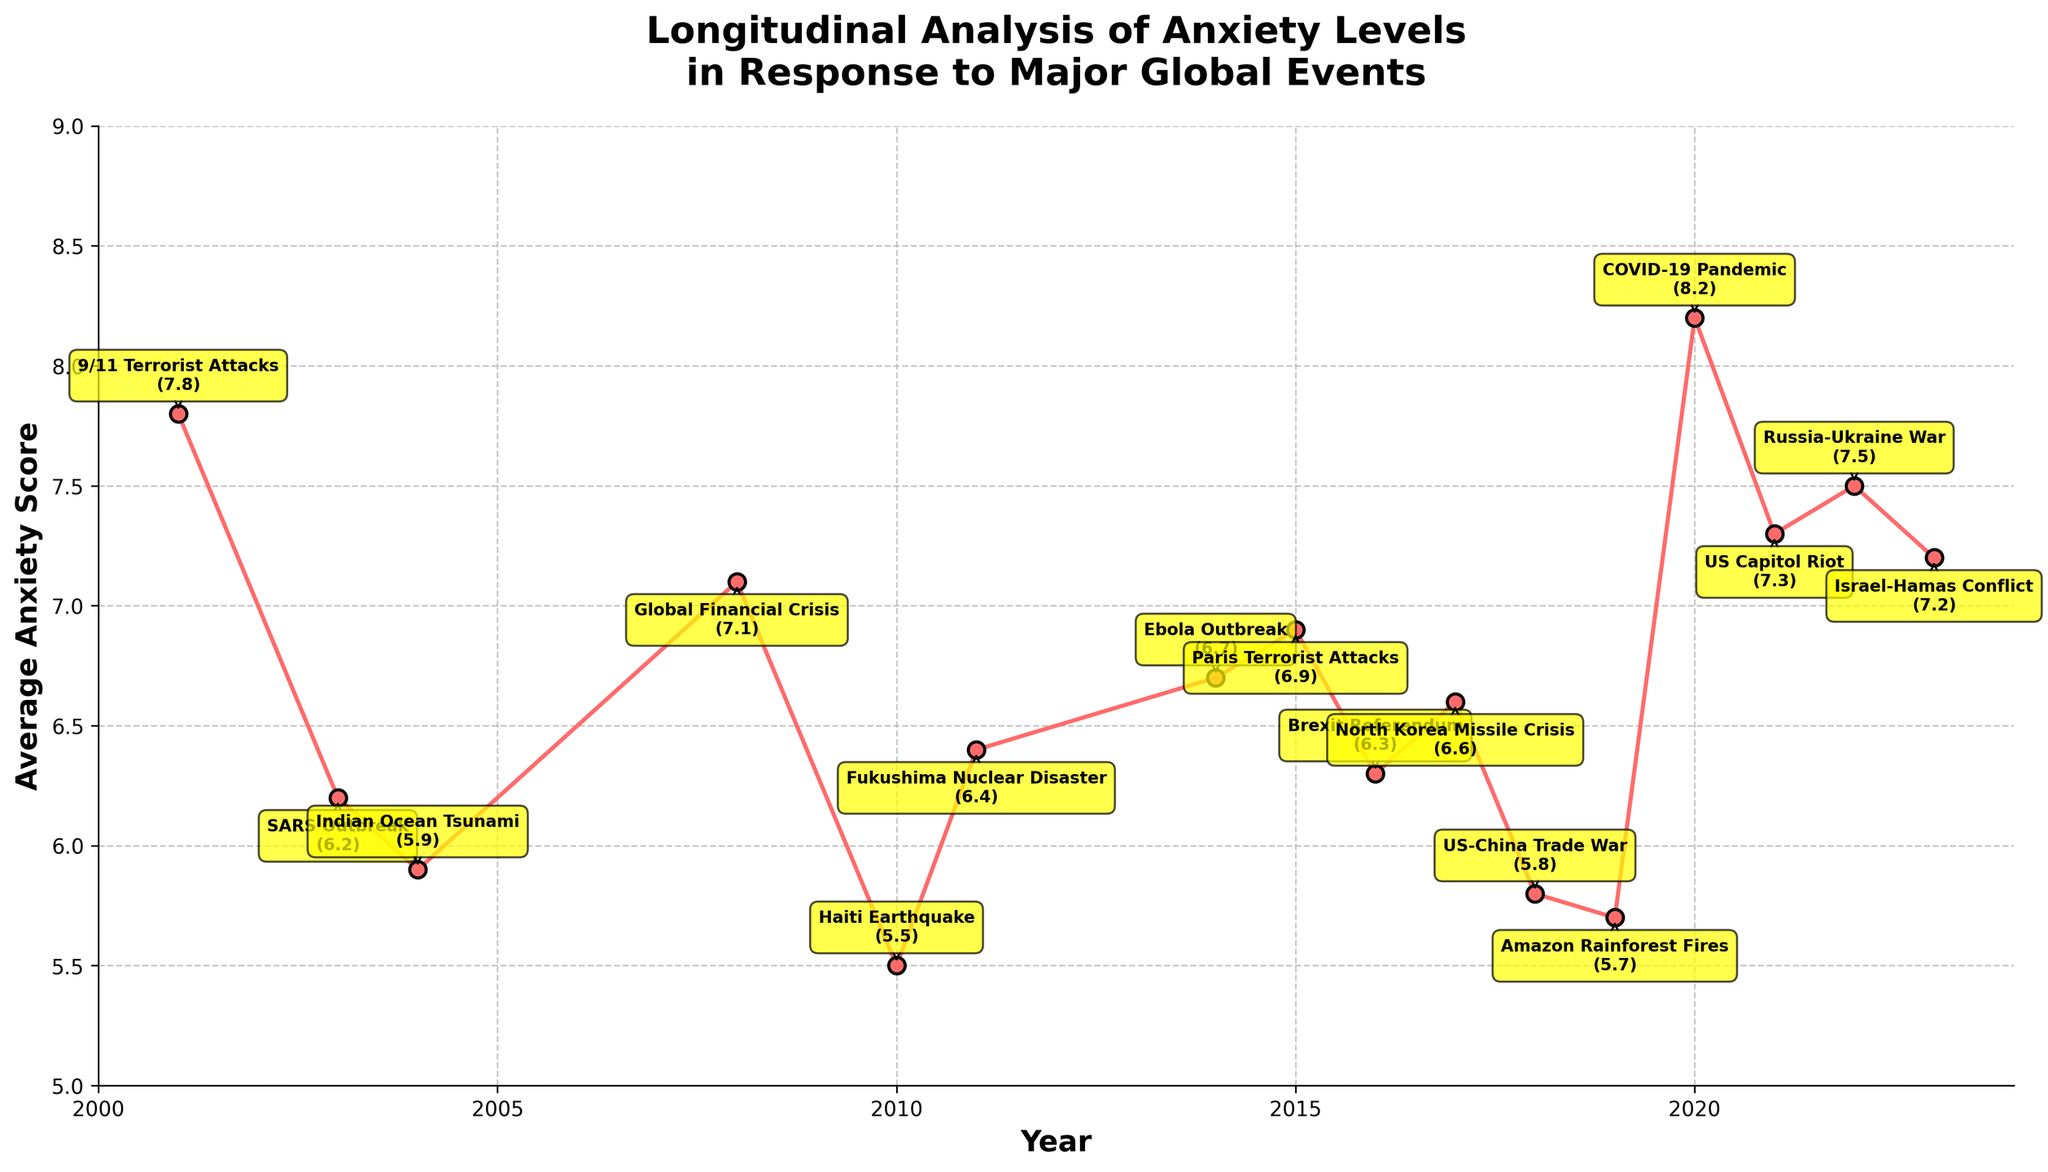What is the average anxiety score for the events in the years 2010, 2011, and 2012? To find the average anxiety score for these years, sum up the scores for the years 2010, 2011, and 2012, which are 5.5, 6.4, and 0 respectively (no data for 2012). Then divide by the number of years, which is 3. Therefore, (5.5 + 6.4 + 0) / 3 = 11.9 / 3
Answer: 3.97 Which global event in the figure is associated with the highest anxiety score? To identify the event with the highest anxiety score, visually inspect the points on the line chart and look for the one with the highest value. The highest value is 8.2 in the year 2020, corresponding to the COVID-19 Pandemic
Answer: COVID-19 Pandemic How did the anxiety scores change from the Global Financial Crisis in 2008 to the Haiti Earthquake in 2010? Inspect the values at the points for 2008 and 2010. The Global Financial Crisis in 2008 has an anxiety score of 7.1, whereas the Haiti Earthquake in 2010 has a score of 5.5. Calculate the difference: 7.1 - 5.5 = 1.6
Answer: Decreased by 1.6 What is the trend in anxiety scores observed from 2018 to 2020? Examine the points in the years 2018, 2019, and 2020. In 2018, the score is 5.8; in 2019, it’s 5.7, and in 2020, it rises to 8.2. The trend shows a decrease initially from 2018 to 2019, followed by a significant increase from 2019 to 2020
Answer: Decrease then sharp increase Which year had a higher anxiety score: the SARS outbreak in 2003 or the Fukushima Nuclear Disaster in 2011? Compare the scores visually. The SARS outbreak in 2003 has a score of 6.2, while the Fukushima Nuclear Disaster in 2011 has a score of 6.4. 6.4 is higher than 6.2
Answer: 2011 